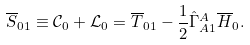Convert formula to latex. <formula><loc_0><loc_0><loc_500><loc_500>\overline { S } _ { 0 1 } \equiv \mathcal { C } _ { 0 } + \mathcal { L } _ { 0 } = \overline { T } _ { 0 1 } - \frac { 1 } { 2 } \hat { \Gamma } ^ { A } _ { A 1 } \overline { H } _ { 0 } .</formula> 